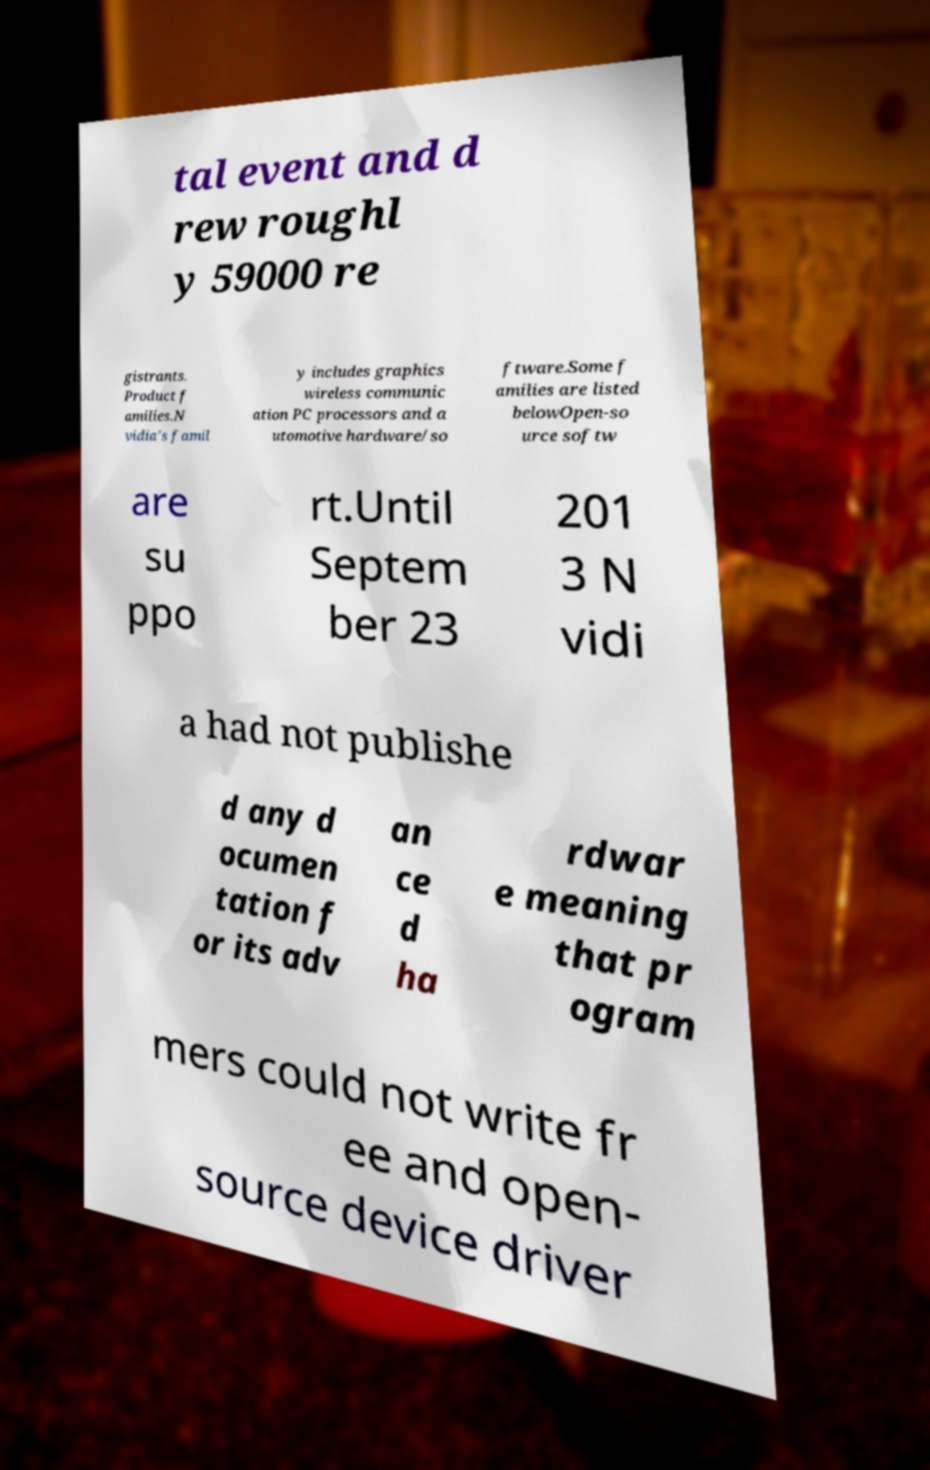For documentation purposes, I need the text within this image transcribed. Could you provide that? tal event and d rew roughl y 59000 re gistrants. Product f amilies.N vidia's famil y includes graphics wireless communic ation PC processors and a utomotive hardware/so ftware.Some f amilies are listed belowOpen-so urce softw are su ppo rt.Until Septem ber 23 201 3 N vidi a had not publishe d any d ocumen tation f or its adv an ce d ha rdwar e meaning that pr ogram mers could not write fr ee and open- source device driver 